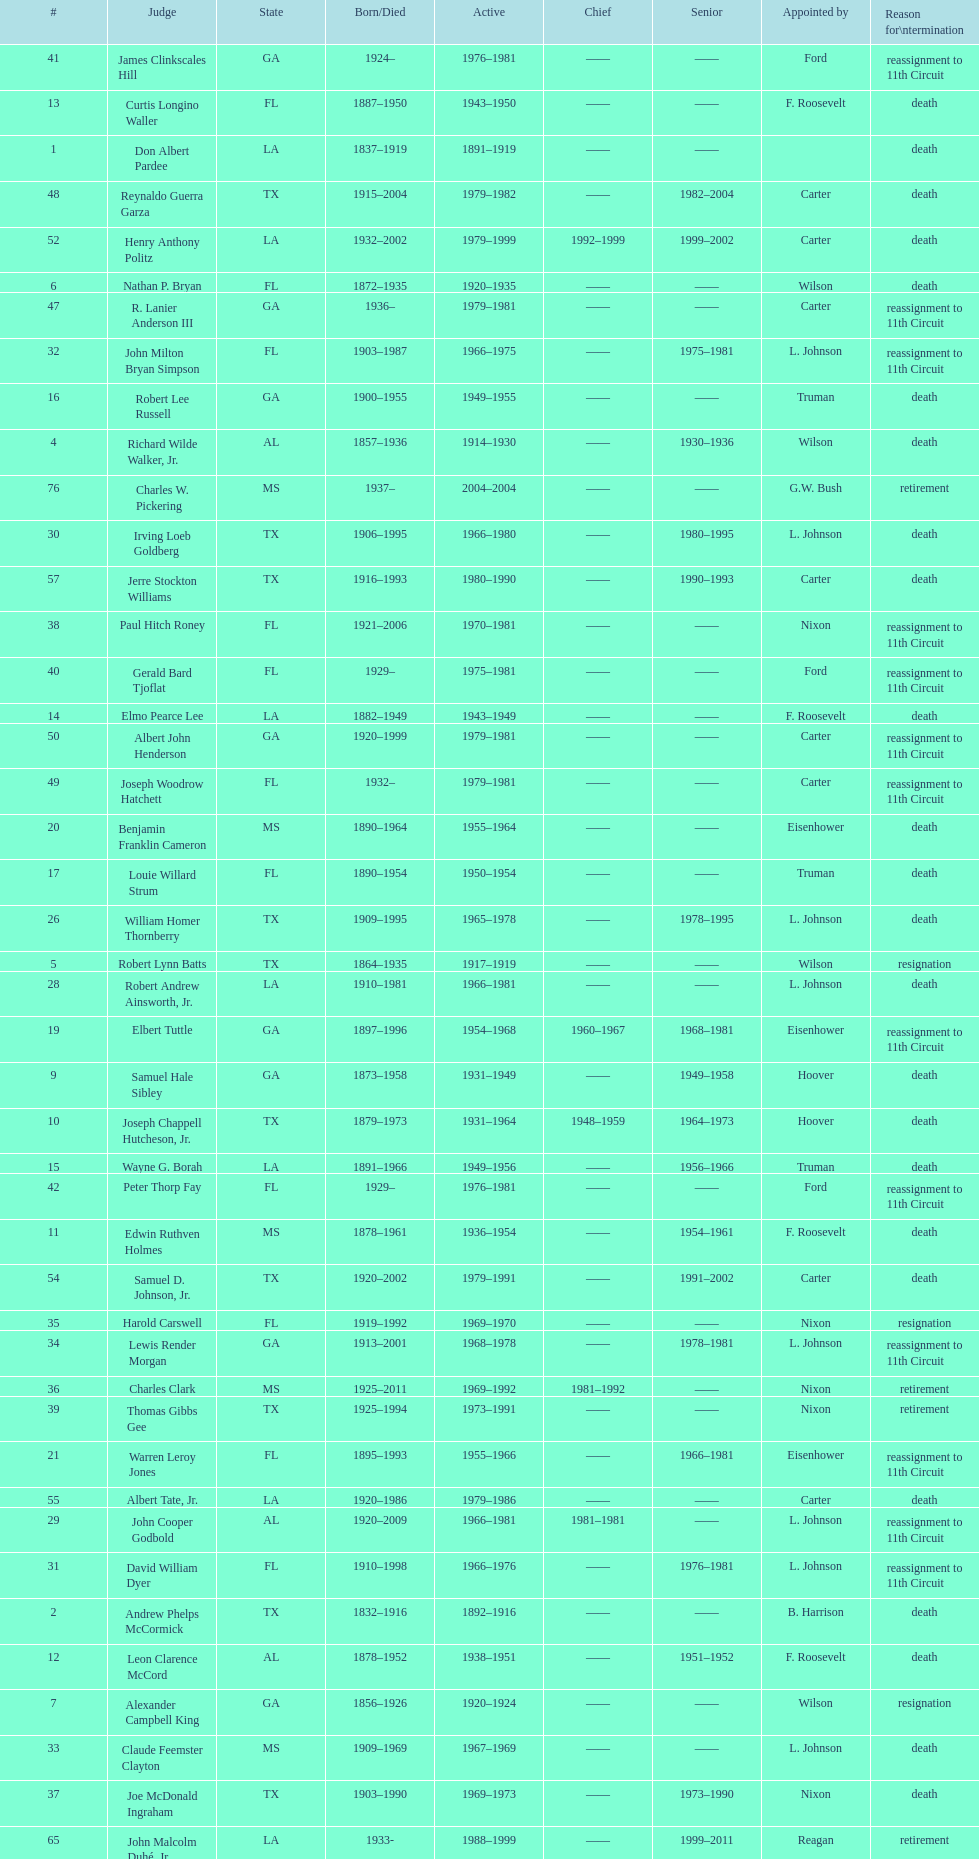Who was the first judge from florida to serve the position? Nathan P. Bryan. 